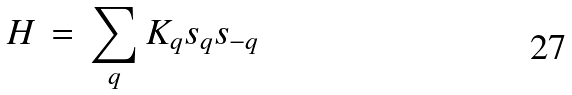Convert formula to latex. <formula><loc_0><loc_0><loc_500><loc_500>H \, = \, \sum _ { q } K _ { q } { s } _ { q } { s } _ { - q }</formula> 